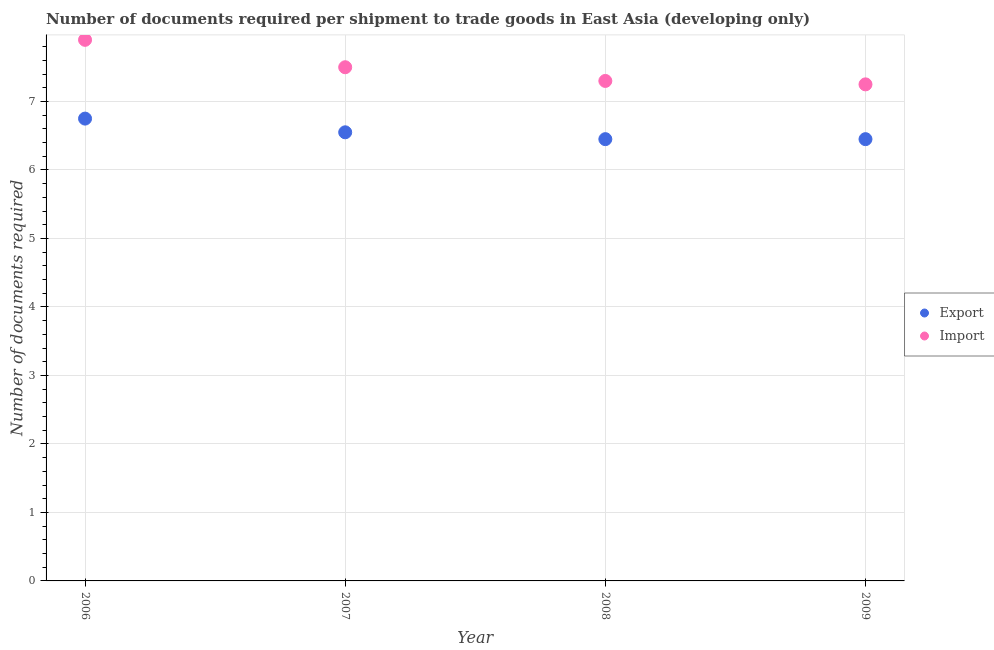What is the number of documents required to export goods in 2006?
Your response must be concise. 6.75. Across all years, what is the maximum number of documents required to import goods?
Your answer should be compact. 7.9. Across all years, what is the minimum number of documents required to import goods?
Your response must be concise. 7.25. What is the total number of documents required to import goods in the graph?
Provide a succinct answer. 29.95. What is the difference between the number of documents required to export goods in 2007 and that in 2008?
Offer a very short reply. 0.1. What is the average number of documents required to import goods per year?
Give a very brief answer. 7.49. In the year 2008, what is the difference between the number of documents required to import goods and number of documents required to export goods?
Ensure brevity in your answer.  0.85. What is the ratio of the number of documents required to import goods in 2006 to that in 2007?
Give a very brief answer. 1.05. Is the number of documents required to import goods in 2007 less than that in 2008?
Make the answer very short. No. Is the difference between the number of documents required to import goods in 2006 and 2008 greater than the difference between the number of documents required to export goods in 2006 and 2008?
Give a very brief answer. Yes. What is the difference between the highest and the second highest number of documents required to export goods?
Provide a succinct answer. 0.2. What is the difference between the highest and the lowest number of documents required to export goods?
Your answer should be compact. 0.3. In how many years, is the number of documents required to export goods greater than the average number of documents required to export goods taken over all years?
Make the answer very short. 1. Does the number of documents required to import goods monotonically increase over the years?
Provide a succinct answer. No. Is the number of documents required to export goods strictly greater than the number of documents required to import goods over the years?
Your answer should be very brief. No. How many dotlines are there?
Make the answer very short. 2. Does the graph contain any zero values?
Make the answer very short. No. Does the graph contain grids?
Provide a short and direct response. Yes. Where does the legend appear in the graph?
Offer a terse response. Center right. How many legend labels are there?
Keep it short and to the point. 2. How are the legend labels stacked?
Make the answer very short. Vertical. What is the title of the graph?
Provide a short and direct response. Number of documents required per shipment to trade goods in East Asia (developing only). Does "Working capital" appear as one of the legend labels in the graph?
Offer a very short reply. No. What is the label or title of the Y-axis?
Your answer should be compact. Number of documents required. What is the Number of documents required of Export in 2006?
Make the answer very short. 6.75. What is the Number of documents required in Export in 2007?
Make the answer very short. 6.55. What is the Number of documents required in Export in 2008?
Provide a short and direct response. 6.45. What is the Number of documents required of Import in 2008?
Offer a terse response. 7.3. What is the Number of documents required of Export in 2009?
Offer a terse response. 6.45. What is the Number of documents required in Import in 2009?
Offer a very short reply. 7.25. Across all years, what is the maximum Number of documents required in Export?
Offer a very short reply. 6.75. Across all years, what is the maximum Number of documents required in Import?
Your response must be concise. 7.9. Across all years, what is the minimum Number of documents required in Export?
Offer a terse response. 6.45. Across all years, what is the minimum Number of documents required in Import?
Your answer should be compact. 7.25. What is the total Number of documents required in Export in the graph?
Keep it short and to the point. 26.2. What is the total Number of documents required in Import in the graph?
Your answer should be very brief. 29.95. What is the difference between the Number of documents required of Export in 2006 and that in 2007?
Make the answer very short. 0.2. What is the difference between the Number of documents required in Import in 2006 and that in 2007?
Keep it short and to the point. 0.4. What is the difference between the Number of documents required in Export in 2006 and that in 2008?
Keep it short and to the point. 0.3. What is the difference between the Number of documents required of Export in 2006 and that in 2009?
Provide a short and direct response. 0.3. What is the difference between the Number of documents required in Import in 2006 and that in 2009?
Offer a terse response. 0.65. What is the difference between the Number of documents required of Export in 2007 and that in 2009?
Provide a succinct answer. 0.1. What is the difference between the Number of documents required in Export in 2008 and that in 2009?
Ensure brevity in your answer.  0. What is the difference between the Number of documents required of Export in 2006 and the Number of documents required of Import in 2007?
Provide a succinct answer. -0.75. What is the difference between the Number of documents required of Export in 2006 and the Number of documents required of Import in 2008?
Ensure brevity in your answer.  -0.55. What is the difference between the Number of documents required in Export in 2006 and the Number of documents required in Import in 2009?
Offer a very short reply. -0.5. What is the difference between the Number of documents required of Export in 2007 and the Number of documents required of Import in 2008?
Keep it short and to the point. -0.75. What is the average Number of documents required of Export per year?
Make the answer very short. 6.55. What is the average Number of documents required in Import per year?
Offer a terse response. 7.49. In the year 2006, what is the difference between the Number of documents required in Export and Number of documents required in Import?
Offer a terse response. -1.15. In the year 2007, what is the difference between the Number of documents required of Export and Number of documents required of Import?
Give a very brief answer. -0.95. In the year 2008, what is the difference between the Number of documents required of Export and Number of documents required of Import?
Offer a terse response. -0.85. What is the ratio of the Number of documents required in Export in 2006 to that in 2007?
Offer a terse response. 1.03. What is the ratio of the Number of documents required of Import in 2006 to that in 2007?
Your response must be concise. 1.05. What is the ratio of the Number of documents required of Export in 2006 to that in 2008?
Ensure brevity in your answer.  1.05. What is the ratio of the Number of documents required in Import in 2006 to that in 2008?
Provide a succinct answer. 1.08. What is the ratio of the Number of documents required in Export in 2006 to that in 2009?
Offer a very short reply. 1.05. What is the ratio of the Number of documents required of Import in 2006 to that in 2009?
Make the answer very short. 1.09. What is the ratio of the Number of documents required in Export in 2007 to that in 2008?
Give a very brief answer. 1.02. What is the ratio of the Number of documents required in Import in 2007 to that in 2008?
Provide a succinct answer. 1.03. What is the ratio of the Number of documents required of Export in 2007 to that in 2009?
Keep it short and to the point. 1.02. What is the ratio of the Number of documents required in Import in 2007 to that in 2009?
Offer a very short reply. 1.03. What is the difference between the highest and the lowest Number of documents required of Import?
Your answer should be compact. 0.65. 